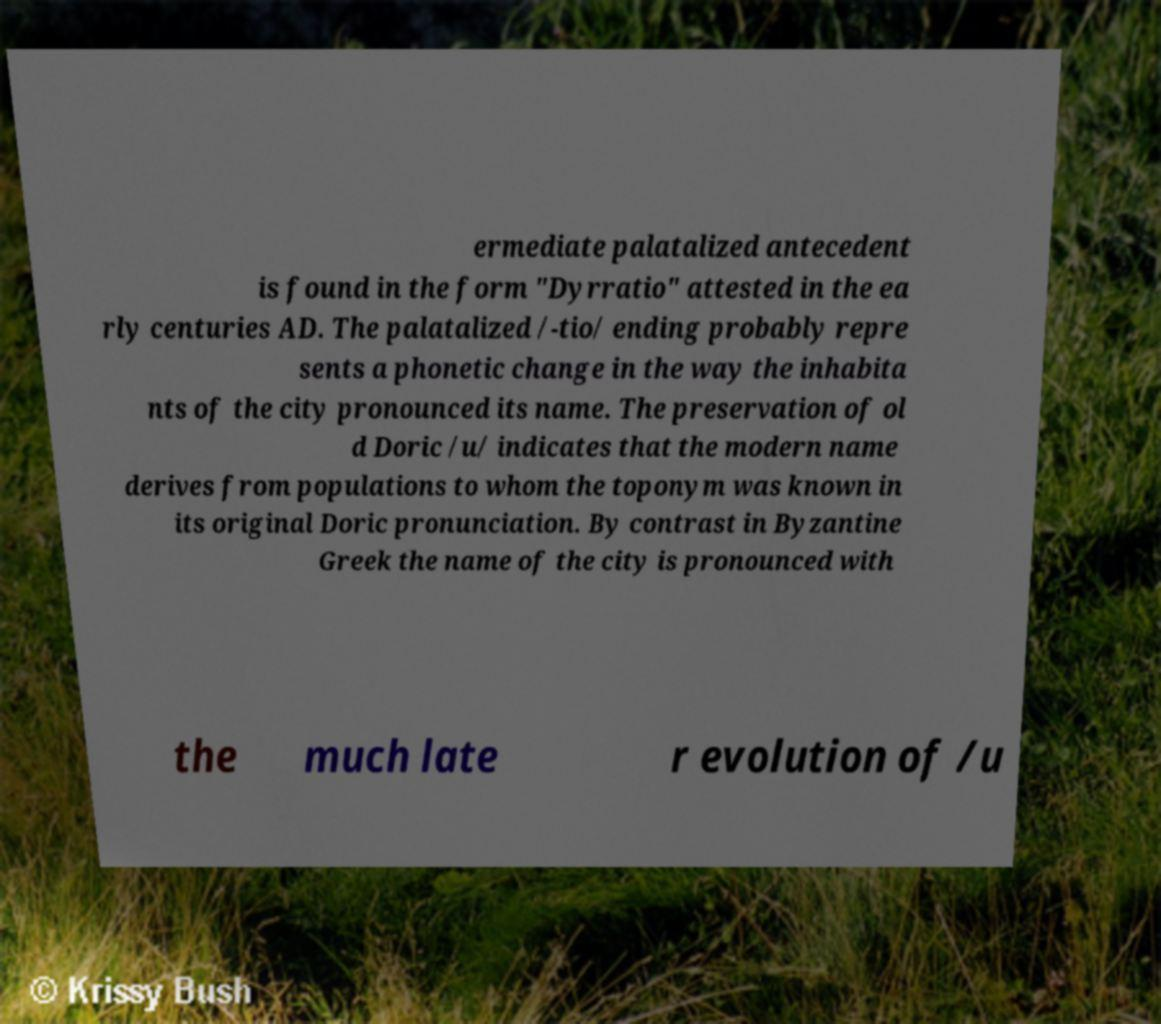There's text embedded in this image that I need extracted. Can you transcribe it verbatim? ermediate palatalized antecedent is found in the form "Dyrratio" attested in the ea rly centuries AD. The palatalized /-tio/ ending probably repre sents a phonetic change in the way the inhabita nts of the city pronounced its name. The preservation of ol d Doric /u/ indicates that the modern name derives from populations to whom the toponym was known in its original Doric pronunciation. By contrast in Byzantine Greek the name of the city is pronounced with the much late r evolution of /u 